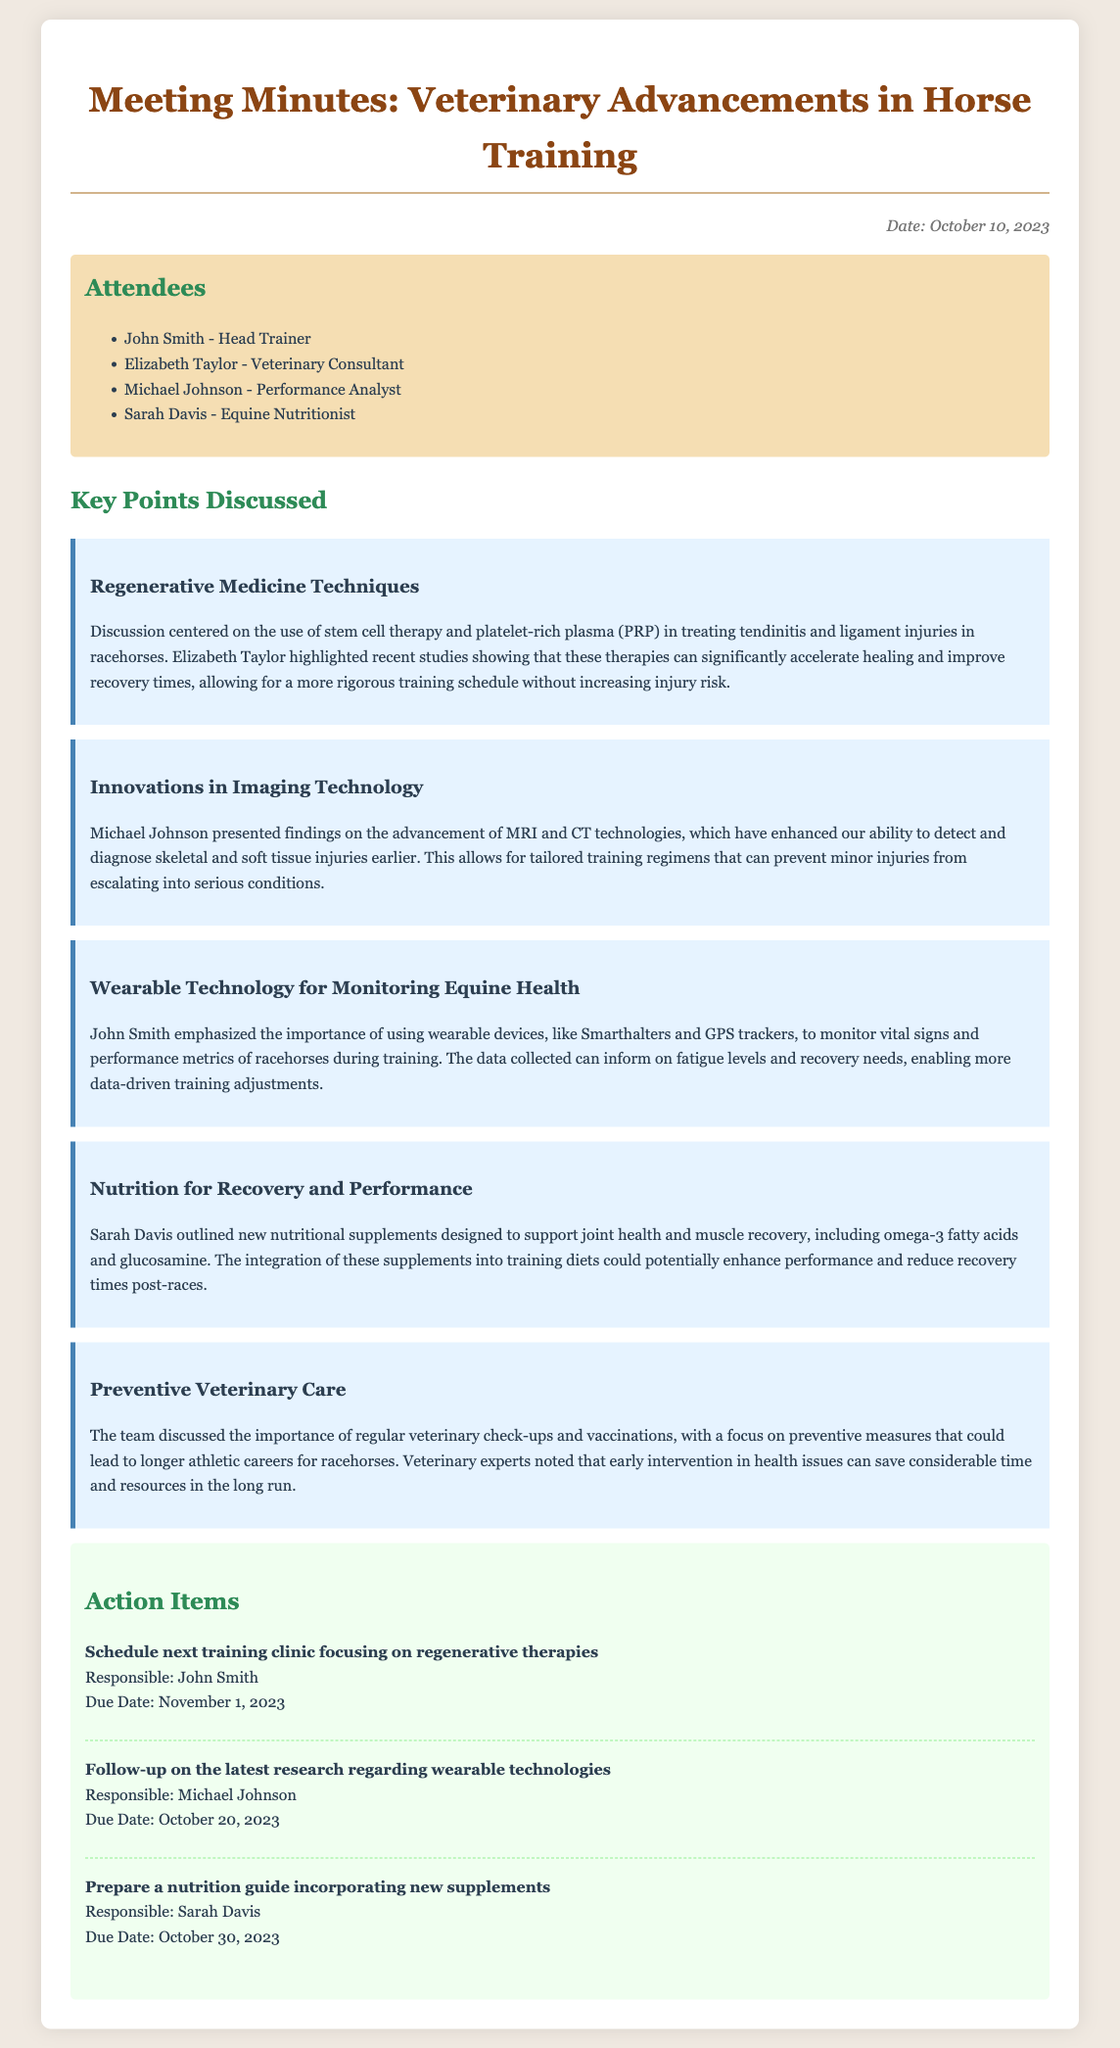what date was the meeting held? The date of the meeting is explicitly stated in the document as October 10, 2023.
Answer: October 10, 2023 who is the veterinary consultant at the meeting? The document lists Elizabeth Taylor as the veterinary consultant among the attendees.
Answer: Elizabeth Taylor what therapy was discussed for treating tendinitis? The minute details the discussion on the use of stem cell therapy and platelet-rich plasma (PRP) for treating tendinitis.
Answer: stem cell therapy and platelet-rich plasma (PRP) what technology advancements were highlighted by Michael Johnson? Michael Johnson presented advancements in MRI and CT technologies regarding injury detection and diagnosis.
Answer: MRI and CT technologies who is responsible for preparing a nutrition guide? The action item specifies that Sarah Davis is responsible for preparing the nutrition guide.
Answer: Sarah Davis what was emphasized about wearable technology? The discussion emphasized the importance of using wearable devices for monitoring vital signs and performance metrics in racehorses.
Answer: monitoring vital signs and performance metrics what type of medicine techniques were discussed? The meeting discussed regenerative medicine techniques, particularly in relation to healing and recovery in racehorses.
Answer: regenerative medicine techniques when is the due date for following up on wearable technologies? The document specifies that the follow-up on wearable technologies is due on October 20, 2023.
Answer: October 20, 2023 what is the main focus of preventive veterinary care discussed in the meeting? The main focus of the preventive veterinary care discussion was on regular check-ups and early intervention for racehorse health issues.
Answer: regular check-ups and early intervention 